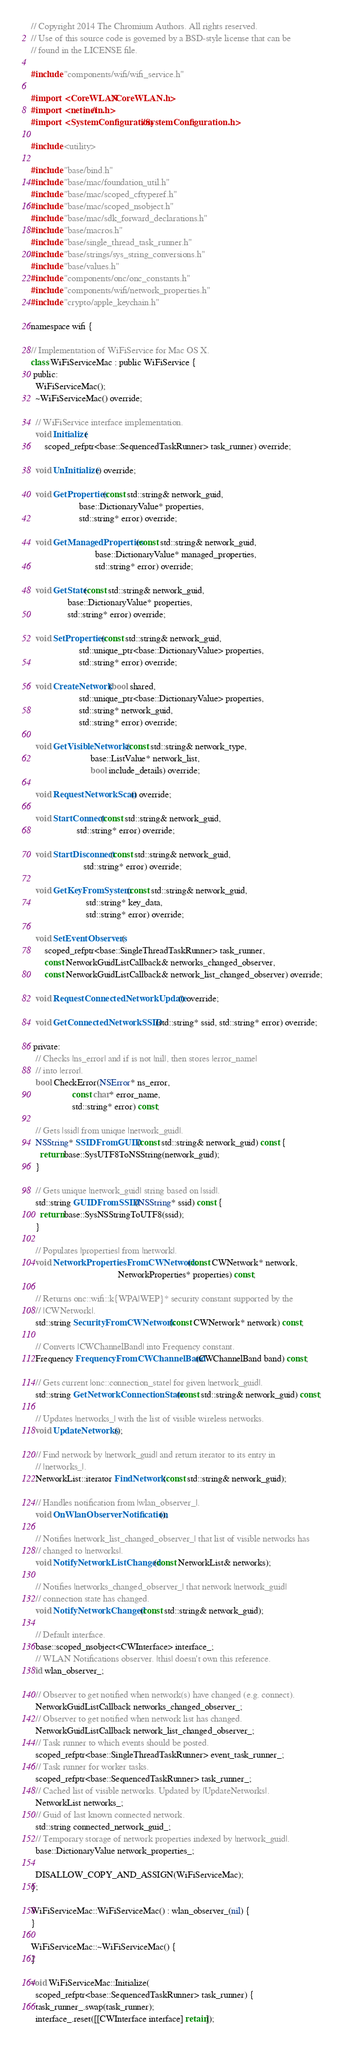<code> <loc_0><loc_0><loc_500><loc_500><_ObjectiveC_>// Copyright 2014 The Chromium Authors. All rights reserved.
// Use of this source code is governed by a BSD-style license that can be
// found in the LICENSE file.

#include "components/wifi/wifi_service.h"

#import <CoreWLAN/CoreWLAN.h>
#import <netinet/in.h>
#import <SystemConfiguration/SystemConfiguration.h>

#include <utility>

#include "base/bind.h"
#include "base/mac/foundation_util.h"
#include "base/mac/scoped_cftyperef.h"
#include "base/mac/scoped_nsobject.h"
#include "base/mac/sdk_forward_declarations.h"
#include "base/macros.h"
#include "base/single_thread_task_runner.h"
#include "base/strings/sys_string_conversions.h"
#include "base/values.h"
#include "components/onc/onc_constants.h"
#include "components/wifi/network_properties.h"
#include "crypto/apple_keychain.h"

namespace wifi {

// Implementation of WiFiService for Mac OS X.
class WiFiServiceMac : public WiFiService {
 public:
  WiFiServiceMac();
  ~WiFiServiceMac() override;

  // WiFiService interface implementation.
  void Initialize(
      scoped_refptr<base::SequencedTaskRunner> task_runner) override;

  void UnInitialize() override;

  void GetProperties(const std::string& network_guid,
                     base::DictionaryValue* properties,
                     std::string* error) override;

  void GetManagedProperties(const std::string& network_guid,
                            base::DictionaryValue* managed_properties,
                            std::string* error) override;

  void GetState(const std::string& network_guid,
                base::DictionaryValue* properties,
                std::string* error) override;

  void SetProperties(const std::string& network_guid,
                     std::unique_ptr<base::DictionaryValue> properties,
                     std::string* error) override;

  void CreateNetwork(bool shared,
                     std::unique_ptr<base::DictionaryValue> properties,
                     std::string* network_guid,
                     std::string* error) override;

  void GetVisibleNetworks(const std::string& network_type,
                          base::ListValue* network_list,
                          bool include_details) override;

  void RequestNetworkScan() override;

  void StartConnect(const std::string& network_guid,
                    std::string* error) override;

  void StartDisconnect(const std::string& network_guid,
                       std::string* error) override;

  void GetKeyFromSystem(const std::string& network_guid,
                        std::string* key_data,
                        std::string* error) override;

  void SetEventObservers(
      scoped_refptr<base::SingleThreadTaskRunner> task_runner,
      const NetworkGuidListCallback& networks_changed_observer,
      const NetworkGuidListCallback& network_list_changed_observer) override;

  void RequestConnectedNetworkUpdate() override;

  void GetConnectedNetworkSSID(std::string* ssid, std::string* error) override;

 private:
  // Checks |ns_error| and if is not |nil|, then stores |error_name|
  // into |error|.
  bool CheckError(NSError* ns_error,
                  const char* error_name,
                  std::string* error) const;

  // Gets |ssid| from unique |network_guid|.
  NSString* SSIDFromGUID(const std::string& network_guid) const {
    return base::SysUTF8ToNSString(network_guid);
  }

  // Gets unique |network_guid| string based on |ssid|.
  std::string GUIDFromSSID(NSString* ssid) const {
    return base::SysNSStringToUTF8(ssid);
  }

  // Populates |properties| from |network|.
  void NetworkPropertiesFromCWNetwork(const CWNetwork* network,
                                      NetworkProperties* properties) const;

  // Returns onc::wifi::k{WPA|WEP}* security constant supported by the
  // |CWNetwork|.
  std::string SecurityFromCWNetwork(const CWNetwork* network) const;

  // Converts |CWChannelBand| into Frequency constant.
  Frequency FrequencyFromCWChannelBand(CWChannelBand band) const;

  // Gets current |onc::connection_state| for given |network_guid|.
  std::string GetNetworkConnectionState(const std::string& network_guid) const;

  // Updates |networks_| with the list of visible wireless networks.
  void UpdateNetworks();

  // Find network by |network_guid| and return iterator to its entry in
  // |networks_|.
  NetworkList::iterator FindNetwork(const std::string& network_guid);

  // Handles notification from |wlan_observer_|.
  void OnWlanObserverNotification();

  // Notifies |network_list_changed_observer_| that list of visible networks has
  // changed to |networks|.
  void NotifyNetworkListChanged(const NetworkList& networks);

  // Notifies |networks_changed_observer_| that network |network_guid|
  // connection state has changed.
  void NotifyNetworkChanged(const std::string& network_guid);

  // Default interface.
  base::scoped_nsobject<CWInterface> interface_;
  // WLAN Notifications observer. |this| doesn't own this reference.
  id wlan_observer_;

  // Observer to get notified when network(s) have changed (e.g. connect).
  NetworkGuidListCallback networks_changed_observer_;
  // Observer to get notified when network list has changed.
  NetworkGuidListCallback network_list_changed_observer_;
  // Task runner to which events should be posted.
  scoped_refptr<base::SingleThreadTaskRunner> event_task_runner_;
  // Task runner for worker tasks.
  scoped_refptr<base::SequencedTaskRunner> task_runner_;
  // Cached list of visible networks. Updated by |UpdateNetworks|.
  NetworkList networks_;
  // Guid of last known connected network.
  std::string connected_network_guid_;
  // Temporary storage of network properties indexed by |network_guid|.
  base::DictionaryValue network_properties_;

  DISALLOW_COPY_AND_ASSIGN(WiFiServiceMac);
};

WiFiServiceMac::WiFiServiceMac() : wlan_observer_(nil) {
}

WiFiServiceMac::~WiFiServiceMac() {
}

void WiFiServiceMac::Initialize(
  scoped_refptr<base::SequencedTaskRunner> task_runner) {
  task_runner_.swap(task_runner);
  interface_.reset([[CWInterface interface] retain]);</code> 